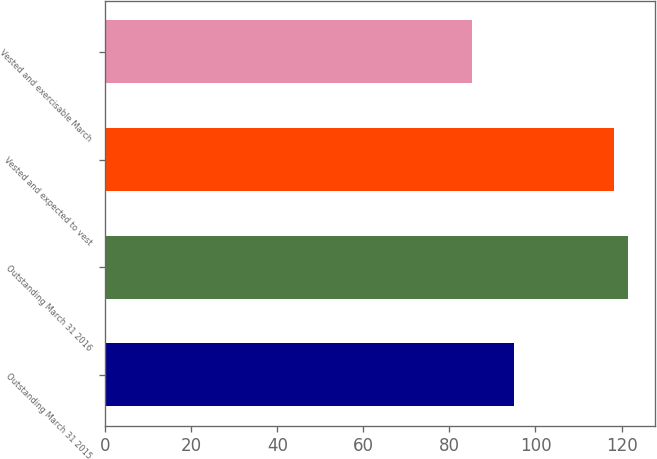<chart> <loc_0><loc_0><loc_500><loc_500><bar_chart><fcel>Outstanding March 31 2015<fcel>Outstanding March 31 2016<fcel>Vested and expected to vest<fcel>Vested and exercisable March<nl><fcel>95.01<fcel>121.59<fcel>118.21<fcel>85.15<nl></chart> 